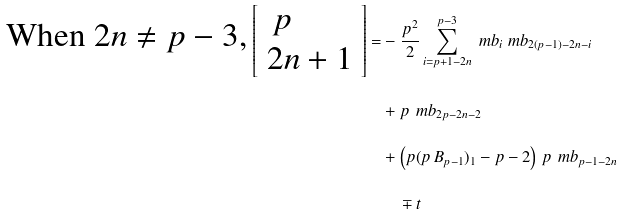<formula> <loc_0><loc_0><loc_500><loc_500>\text {When $2n\neq p-3$,} \, \left [ \begin{array} { l } \, p \, \\ 2 n + 1 \end{array} \right ] = & - \frac { p ^ { 2 } } { 2 } \sum _ { i = p + 1 - 2 n } ^ { p - 3 } \ m b _ { i } \ m b _ { 2 ( p - 1 ) - 2 n - i } \\ & + p \, \ m b _ { 2 p - 2 n - 2 } \\ & + \left ( p ( p \, B _ { p - 1 } ) _ { 1 } - p - 2 \right ) \, p \, \ m b _ { p - 1 - 2 n } \\ & \quad \mp t</formula> 